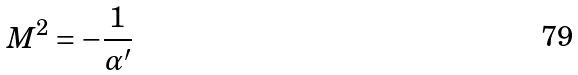<formula> <loc_0><loc_0><loc_500><loc_500>M ^ { 2 } = - \frac { 1 } { \alpha ^ { \prime } }</formula> 